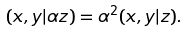Convert formula to latex. <formula><loc_0><loc_0><loc_500><loc_500>( x , y | \alpha z ) = \alpha ^ { 2 } ( x , y | z ) .</formula> 